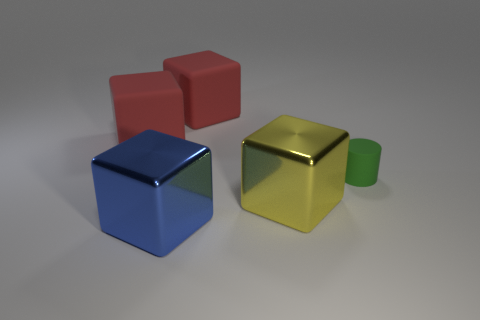Is there anything else that is the same size as the green thing?
Offer a very short reply. No. Does the big metal block that is behind the blue cube have the same color as the small cylinder right of the big yellow shiny thing?
Your response must be concise. No. What is the color of the other metal object that is the same shape as the blue shiny thing?
Offer a terse response. Yellow. Is there anything else that has the same shape as the large blue metallic thing?
Make the answer very short. Yes. Does the large metal thing that is in front of the large yellow thing have the same shape as the red object that is to the left of the blue cube?
Provide a succinct answer. Yes. Does the yellow object have the same size as the metal cube in front of the large yellow metal object?
Keep it short and to the point. Yes. Are there more tiny things than small purple metallic cylinders?
Your answer should be very brief. Yes. Is the material of the small green thing behind the large blue thing the same as the big yellow block that is to the right of the large blue metal thing?
Your answer should be compact. No. What is the blue cube made of?
Provide a short and direct response. Metal. Is the number of cubes that are in front of the small green rubber thing greater than the number of matte cylinders?
Make the answer very short. Yes. 